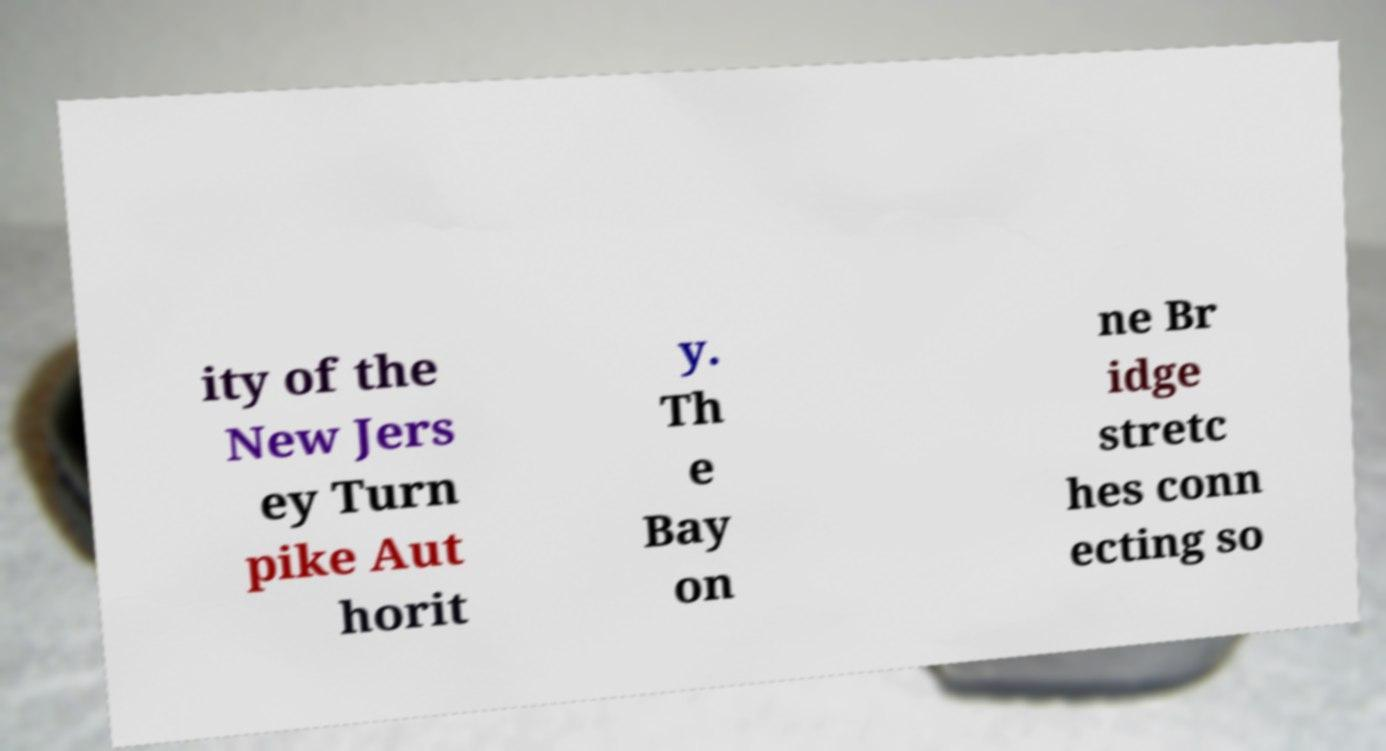For documentation purposes, I need the text within this image transcribed. Could you provide that? ity of the New Jers ey Turn pike Aut horit y. Th e Bay on ne Br idge stretc hes conn ecting so 